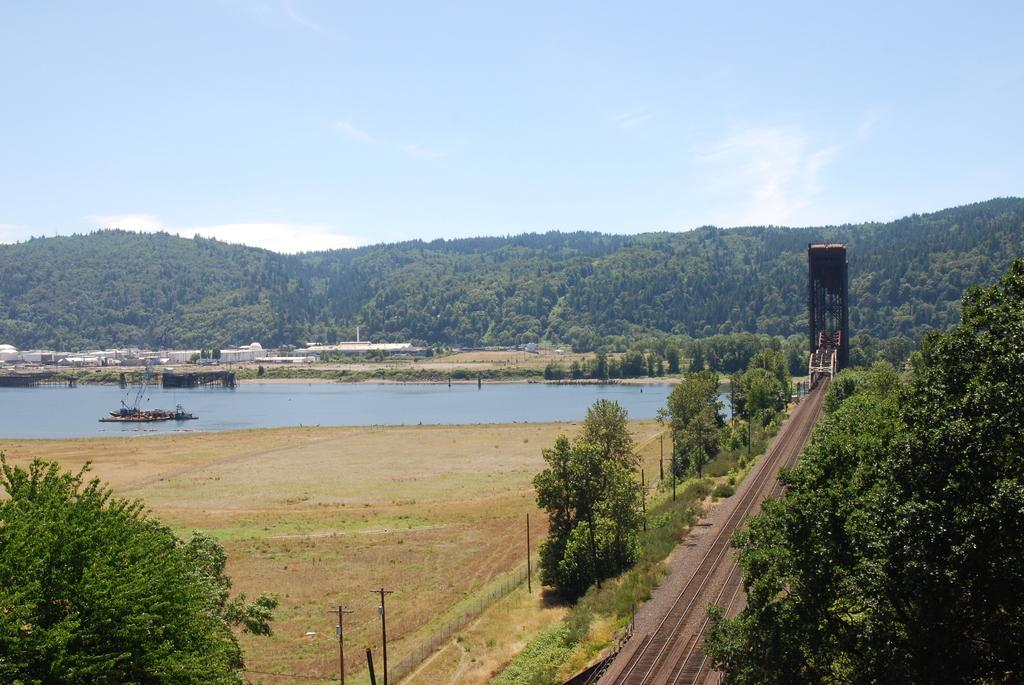What type of transportation infrastructure is present in the image? There is a railway track in the image. What natural elements can be seen in the image? There are trees and water visible in the image. What man-made structures are present in the image? There are poles and a fence in the image. What can be seen in the background of the image? The sky is visible in the background of the image. Where is the cemetery located in the image? There is no cemetery present in the image. What is the height of the head in the image? There is no head present in the image. 